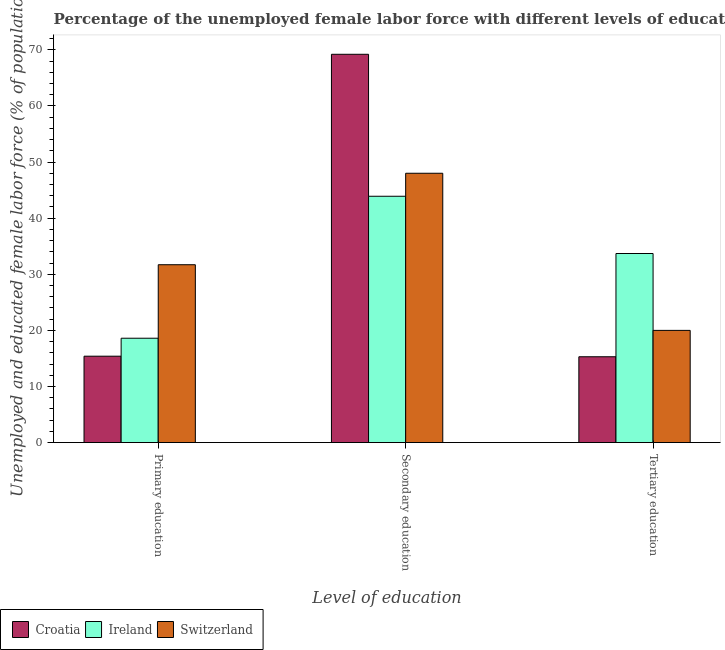How many groups of bars are there?
Your response must be concise. 3. Are the number of bars on each tick of the X-axis equal?
Your answer should be very brief. Yes. How many bars are there on the 2nd tick from the right?
Provide a succinct answer. 3. What is the label of the 1st group of bars from the left?
Make the answer very short. Primary education. What is the percentage of female labor force who received primary education in Ireland?
Ensure brevity in your answer.  18.6. Across all countries, what is the maximum percentage of female labor force who received secondary education?
Your answer should be compact. 69.2. Across all countries, what is the minimum percentage of female labor force who received secondary education?
Ensure brevity in your answer.  43.9. In which country was the percentage of female labor force who received tertiary education maximum?
Give a very brief answer. Ireland. In which country was the percentage of female labor force who received secondary education minimum?
Make the answer very short. Ireland. What is the total percentage of female labor force who received secondary education in the graph?
Your answer should be compact. 161.1. What is the difference between the percentage of female labor force who received secondary education in Switzerland and that in Croatia?
Ensure brevity in your answer.  -21.2. What is the difference between the percentage of female labor force who received secondary education in Croatia and the percentage of female labor force who received primary education in Ireland?
Make the answer very short. 50.6. What is the average percentage of female labor force who received tertiary education per country?
Provide a succinct answer. 23. What is the difference between the percentage of female labor force who received secondary education and percentage of female labor force who received primary education in Ireland?
Provide a succinct answer. 25.3. In how many countries, is the percentage of female labor force who received secondary education greater than 10 %?
Your response must be concise. 3. What is the ratio of the percentage of female labor force who received tertiary education in Croatia to that in Switzerland?
Your answer should be very brief. 0.77. Is the difference between the percentage of female labor force who received primary education in Switzerland and Croatia greater than the difference between the percentage of female labor force who received tertiary education in Switzerland and Croatia?
Your answer should be compact. Yes. What is the difference between the highest and the second highest percentage of female labor force who received tertiary education?
Make the answer very short. 13.7. What is the difference between the highest and the lowest percentage of female labor force who received secondary education?
Provide a short and direct response. 25.3. In how many countries, is the percentage of female labor force who received primary education greater than the average percentage of female labor force who received primary education taken over all countries?
Offer a terse response. 1. Is the sum of the percentage of female labor force who received primary education in Croatia and Switzerland greater than the maximum percentage of female labor force who received secondary education across all countries?
Your response must be concise. No. What does the 3rd bar from the left in Tertiary education represents?
Your answer should be very brief. Switzerland. What does the 1st bar from the right in Secondary education represents?
Provide a short and direct response. Switzerland. Is it the case that in every country, the sum of the percentage of female labor force who received primary education and percentage of female labor force who received secondary education is greater than the percentage of female labor force who received tertiary education?
Your answer should be very brief. Yes. How many bars are there?
Offer a terse response. 9. Are all the bars in the graph horizontal?
Keep it short and to the point. No. Does the graph contain any zero values?
Offer a very short reply. No. Does the graph contain grids?
Offer a very short reply. No. How many legend labels are there?
Make the answer very short. 3. What is the title of the graph?
Provide a succinct answer. Percentage of the unemployed female labor force with different levels of education in countries. What is the label or title of the X-axis?
Keep it short and to the point. Level of education. What is the label or title of the Y-axis?
Provide a succinct answer. Unemployed and educated female labor force (% of population). What is the Unemployed and educated female labor force (% of population) of Croatia in Primary education?
Keep it short and to the point. 15.4. What is the Unemployed and educated female labor force (% of population) in Ireland in Primary education?
Give a very brief answer. 18.6. What is the Unemployed and educated female labor force (% of population) of Switzerland in Primary education?
Give a very brief answer. 31.7. What is the Unemployed and educated female labor force (% of population) of Croatia in Secondary education?
Offer a very short reply. 69.2. What is the Unemployed and educated female labor force (% of population) in Ireland in Secondary education?
Your response must be concise. 43.9. What is the Unemployed and educated female labor force (% of population) of Switzerland in Secondary education?
Offer a very short reply. 48. What is the Unemployed and educated female labor force (% of population) of Croatia in Tertiary education?
Give a very brief answer. 15.3. What is the Unemployed and educated female labor force (% of population) in Ireland in Tertiary education?
Your answer should be compact. 33.7. What is the Unemployed and educated female labor force (% of population) in Switzerland in Tertiary education?
Keep it short and to the point. 20. Across all Level of education, what is the maximum Unemployed and educated female labor force (% of population) of Croatia?
Provide a short and direct response. 69.2. Across all Level of education, what is the maximum Unemployed and educated female labor force (% of population) of Ireland?
Provide a short and direct response. 43.9. Across all Level of education, what is the minimum Unemployed and educated female labor force (% of population) of Croatia?
Your response must be concise. 15.3. Across all Level of education, what is the minimum Unemployed and educated female labor force (% of population) of Ireland?
Offer a terse response. 18.6. Across all Level of education, what is the minimum Unemployed and educated female labor force (% of population) of Switzerland?
Provide a succinct answer. 20. What is the total Unemployed and educated female labor force (% of population) of Croatia in the graph?
Offer a terse response. 99.9. What is the total Unemployed and educated female labor force (% of population) in Ireland in the graph?
Provide a succinct answer. 96.2. What is the total Unemployed and educated female labor force (% of population) of Switzerland in the graph?
Give a very brief answer. 99.7. What is the difference between the Unemployed and educated female labor force (% of population) in Croatia in Primary education and that in Secondary education?
Keep it short and to the point. -53.8. What is the difference between the Unemployed and educated female labor force (% of population) in Ireland in Primary education and that in Secondary education?
Provide a short and direct response. -25.3. What is the difference between the Unemployed and educated female labor force (% of population) of Switzerland in Primary education and that in Secondary education?
Give a very brief answer. -16.3. What is the difference between the Unemployed and educated female labor force (% of population) in Ireland in Primary education and that in Tertiary education?
Offer a terse response. -15.1. What is the difference between the Unemployed and educated female labor force (% of population) in Croatia in Secondary education and that in Tertiary education?
Ensure brevity in your answer.  53.9. What is the difference between the Unemployed and educated female labor force (% of population) of Croatia in Primary education and the Unemployed and educated female labor force (% of population) of Ireland in Secondary education?
Offer a terse response. -28.5. What is the difference between the Unemployed and educated female labor force (% of population) of Croatia in Primary education and the Unemployed and educated female labor force (% of population) of Switzerland in Secondary education?
Offer a terse response. -32.6. What is the difference between the Unemployed and educated female labor force (% of population) of Ireland in Primary education and the Unemployed and educated female labor force (% of population) of Switzerland in Secondary education?
Offer a terse response. -29.4. What is the difference between the Unemployed and educated female labor force (% of population) in Croatia in Primary education and the Unemployed and educated female labor force (% of population) in Ireland in Tertiary education?
Your answer should be compact. -18.3. What is the difference between the Unemployed and educated female labor force (% of population) of Ireland in Primary education and the Unemployed and educated female labor force (% of population) of Switzerland in Tertiary education?
Give a very brief answer. -1.4. What is the difference between the Unemployed and educated female labor force (% of population) of Croatia in Secondary education and the Unemployed and educated female labor force (% of population) of Ireland in Tertiary education?
Provide a short and direct response. 35.5. What is the difference between the Unemployed and educated female labor force (% of population) in Croatia in Secondary education and the Unemployed and educated female labor force (% of population) in Switzerland in Tertiary education?
Your response must be concise. 49.2. What is the difference between the Unemployed and educated female labor force (% of population) of Ireland in Secondary education and the Unemployed and educated female labor force (% of population) of Switzerland in Tertiary education?
Your answer should be very brief. 23.9. What is the average Unemployed and educated female labor force (% of population) of Croatia per Level of education?
Offer a terse response. 33.3. What is the average Unemployed and educated female labor force (% of population) in Ireland per Level of education?
Ensure brevity in your answer.  32.07. What is the average Unemployed and educated female labor force (% of population) in Switzerland per Level of education?
Keep it short and to the point. 33.23. What is the difference between the Unemployed and educated female labor force (% of population) in Croatia and Unemployed and educated female labor force (% of population) in Switzerland in Primary education?
Keep it short and to the point. -16.3. What is the difference between the Unemployed and educated female labor force (% of population) of Croatia and Unemployed and educated female labor force (% of population) of Ireland in Secondary education?
Provide a short and direct response. 25.3. What is the difference between the Unemployed and educated female labor force (% of population) of Croatia and Unemployed and educated female labor force (% of population) of Switzerland in Secondary education?
Keep it short and to the point. 21.2. What is the difference between the Unemployed and educated female labor force (% of population) in Croatia and Unemployed and educated female labor force (% of population) in Ireland in Tertiary education?
Make the answer very short. -18.4. What is the difference between the Unemployed and educated female labor force (% of population) of Ireland and Unemployed and educated female labor force (% of population) of Switzerland in Tertiary education?
Make the answer very short. 13.7. What is the ratio of the Unemployed and educated female labor force (% of population) in Croatia in Primary education to that in Secondary education?
Offer a very short reply. 0.22. What is the ratio of the Unemployed and educated female labor force (% of population) of Ireland in Primary education to that in Secondary education?
Your answer should be compact. 0.42. What is the ratio of the Unemployed and educated female labor force (% of population) in Switzerland in Primary education to that in Secondary education?
Provide a short and direct response. 0.66. What is the ratio of the Unemployed and educated female labor force (% of population) of Ireland in Primary education to that in Tertiary education?
Your answer should be compact. 0.55. What is the ratio of the Unemployed and educated female labor force (% of population) of Switzerland in Primary education to that in Tertiary education?
Make the answer very short. 1.58. What is the ratio of the Unemployed and educated female labor force (% of population) of Croatia in Secondary education to that in Tertiary education?
Offer a very short reply. 4.52. What is the ratio of the Unemployed and educated female labor force (% of population) of Ireland in Secondary education to that in Tertiary education?
Offer a very short reply. 1.3. What is the difference between the highest and the second highest Unemployed and educated female labor force (% of population) of Croatia?
Provide a succinct answer. 53.8. What is the difference between the highest and the second highest Unemployed and educated female labor force (% of population) of Switzerland?
Your answer should be compact. 16.3. What is the difference between the highest and the lowest Unemployed and educated female labor force (% of population) in Croatia?
Offer a terse response. 53.9. What is the difference between the highest and the lowest Unemployed and educated female labor force (% of population) in Ireland?
Ensure brevity in your answer.  25.3. What is the difference between the highest and the lowest Unemployed and educated female labor force (% of population) in Switzerland?
Your response must be concise. 28. 